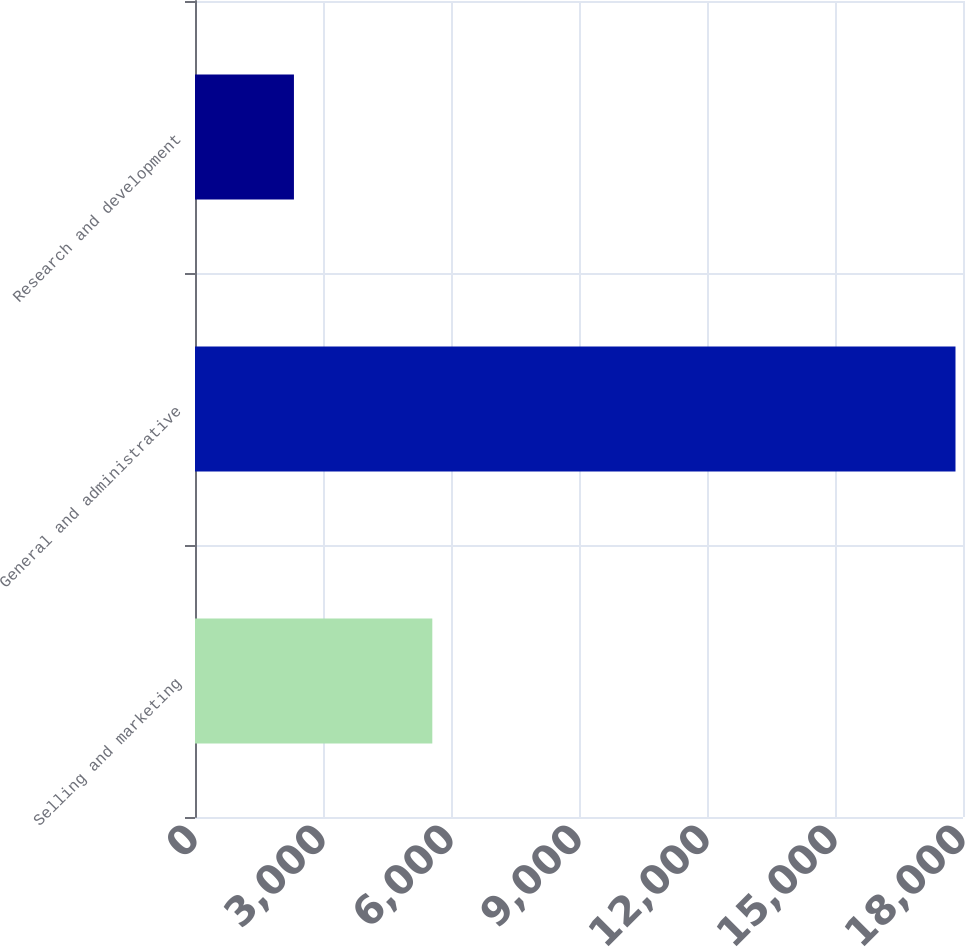<chart> <loc_0><loc_0><loc_500><loc_500><bar_chart><fcel>Selling and marketing<fcel>General and administrative<fcel>Research and development<nl><fcel>5562<fcel>17824<fcel>2319<nl></chart> 